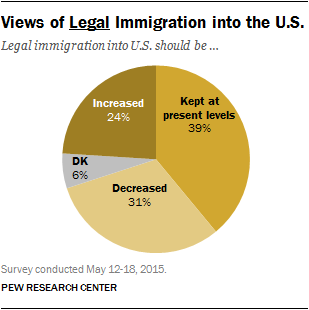Draw attention to some important aspects in this diagram. The value of the largest segment is not 31%. The ratio of the two smallest segments is 1:4, and the answer is yes. 